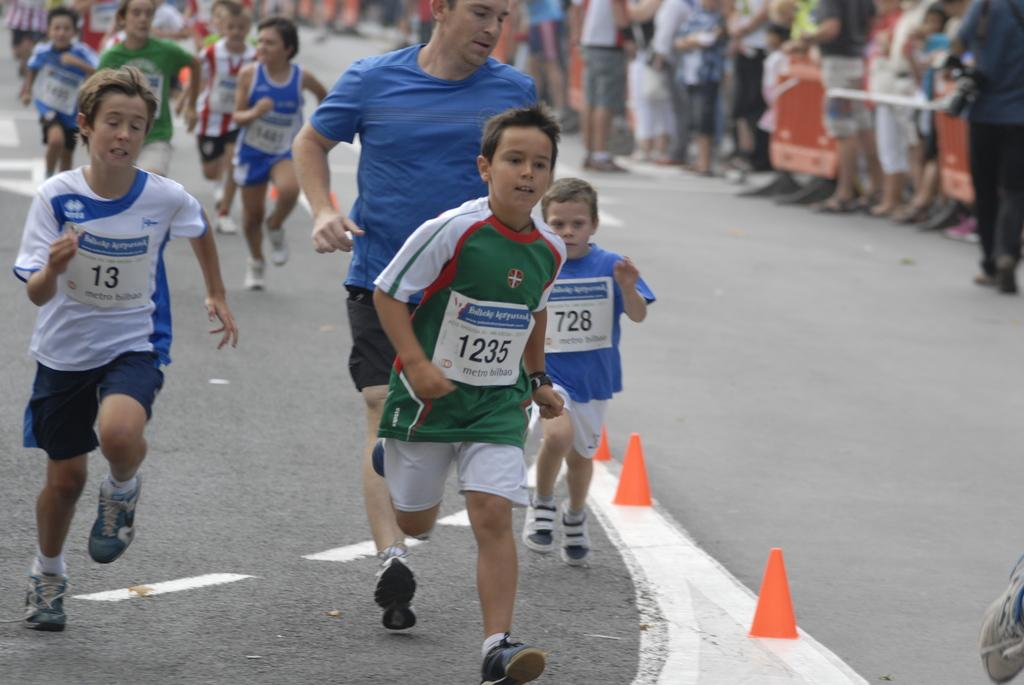What are the people in the image doing? There is a group of people running in the image. Where are the people running? The group of people running is on the road. Are there any other people in the image? Yes, there is a group of people standing on the right side of the image. What is the name of the daughter of the person standing on the right side of the image? There is no mention of a daughter or any specific person in the image, so we cannot determine the name of a daughter. 